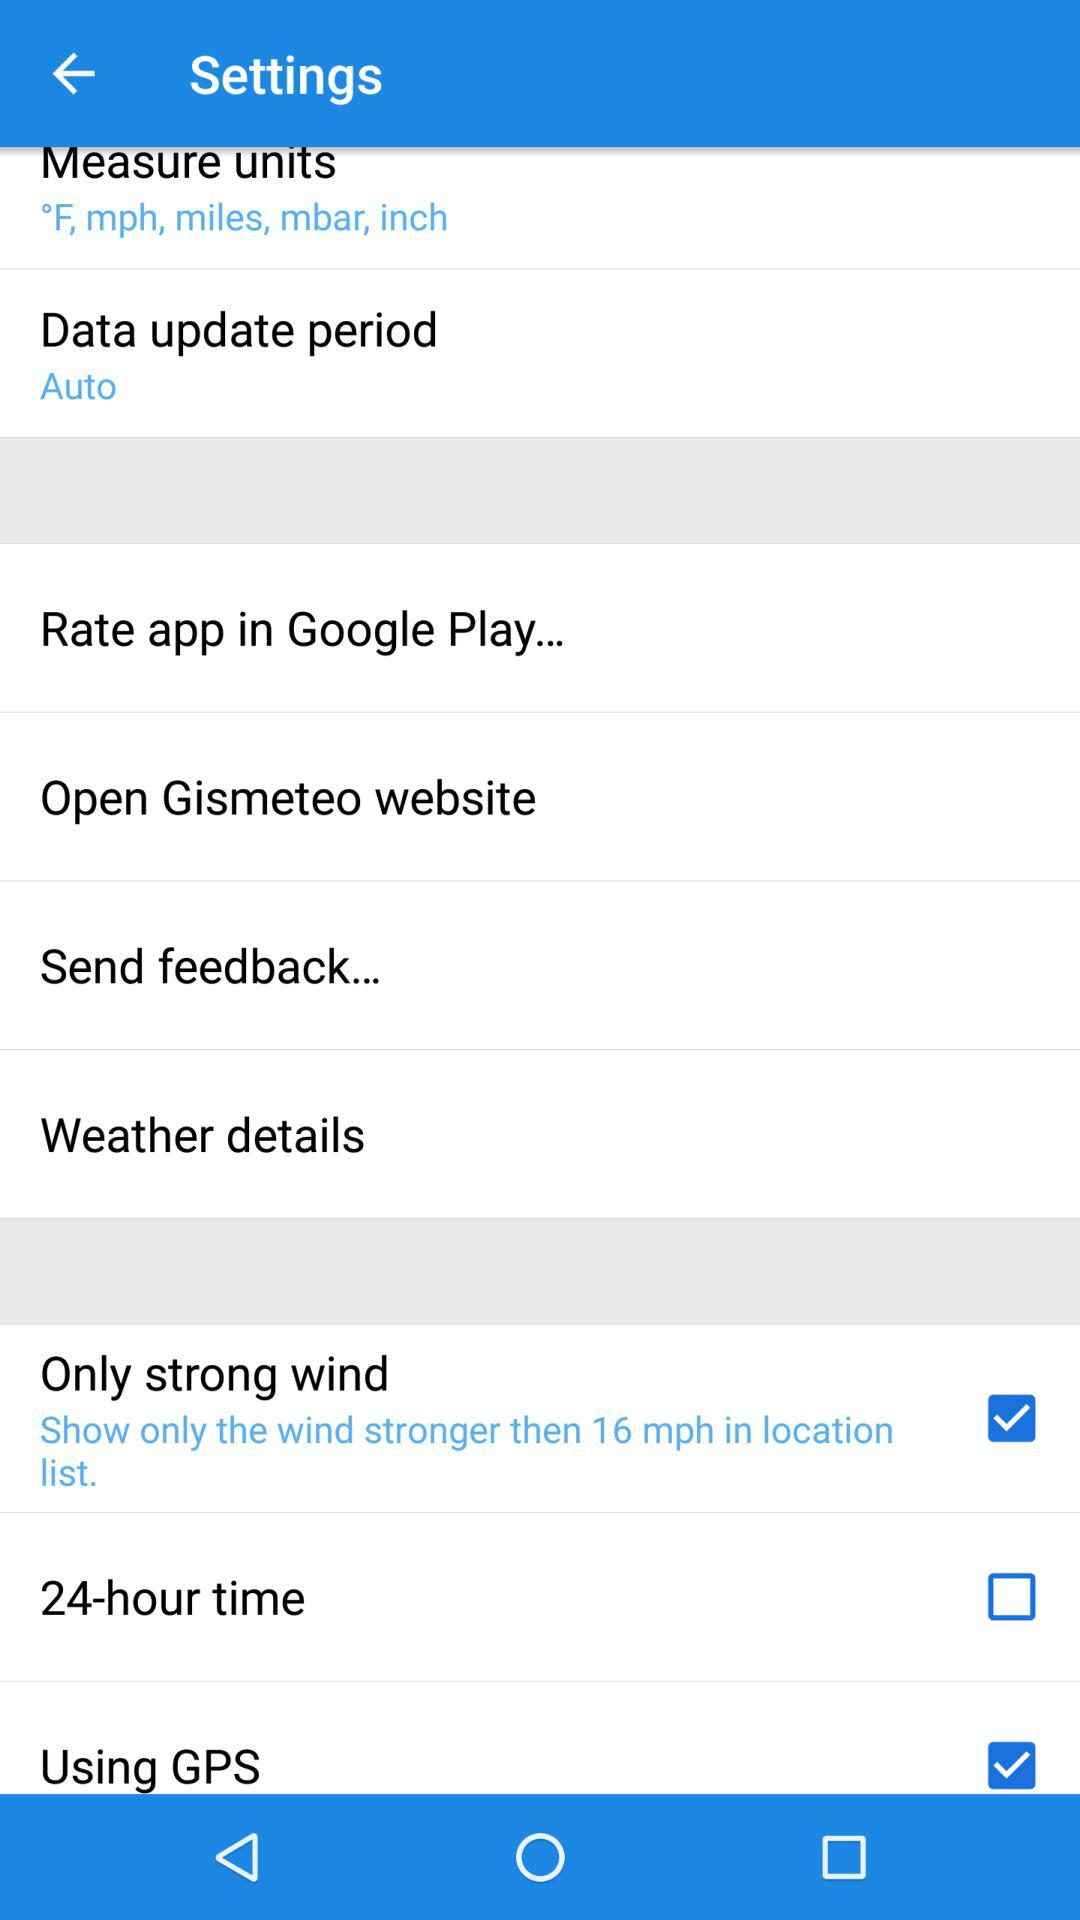What's the status of "Using GPS"? The status is "on". 